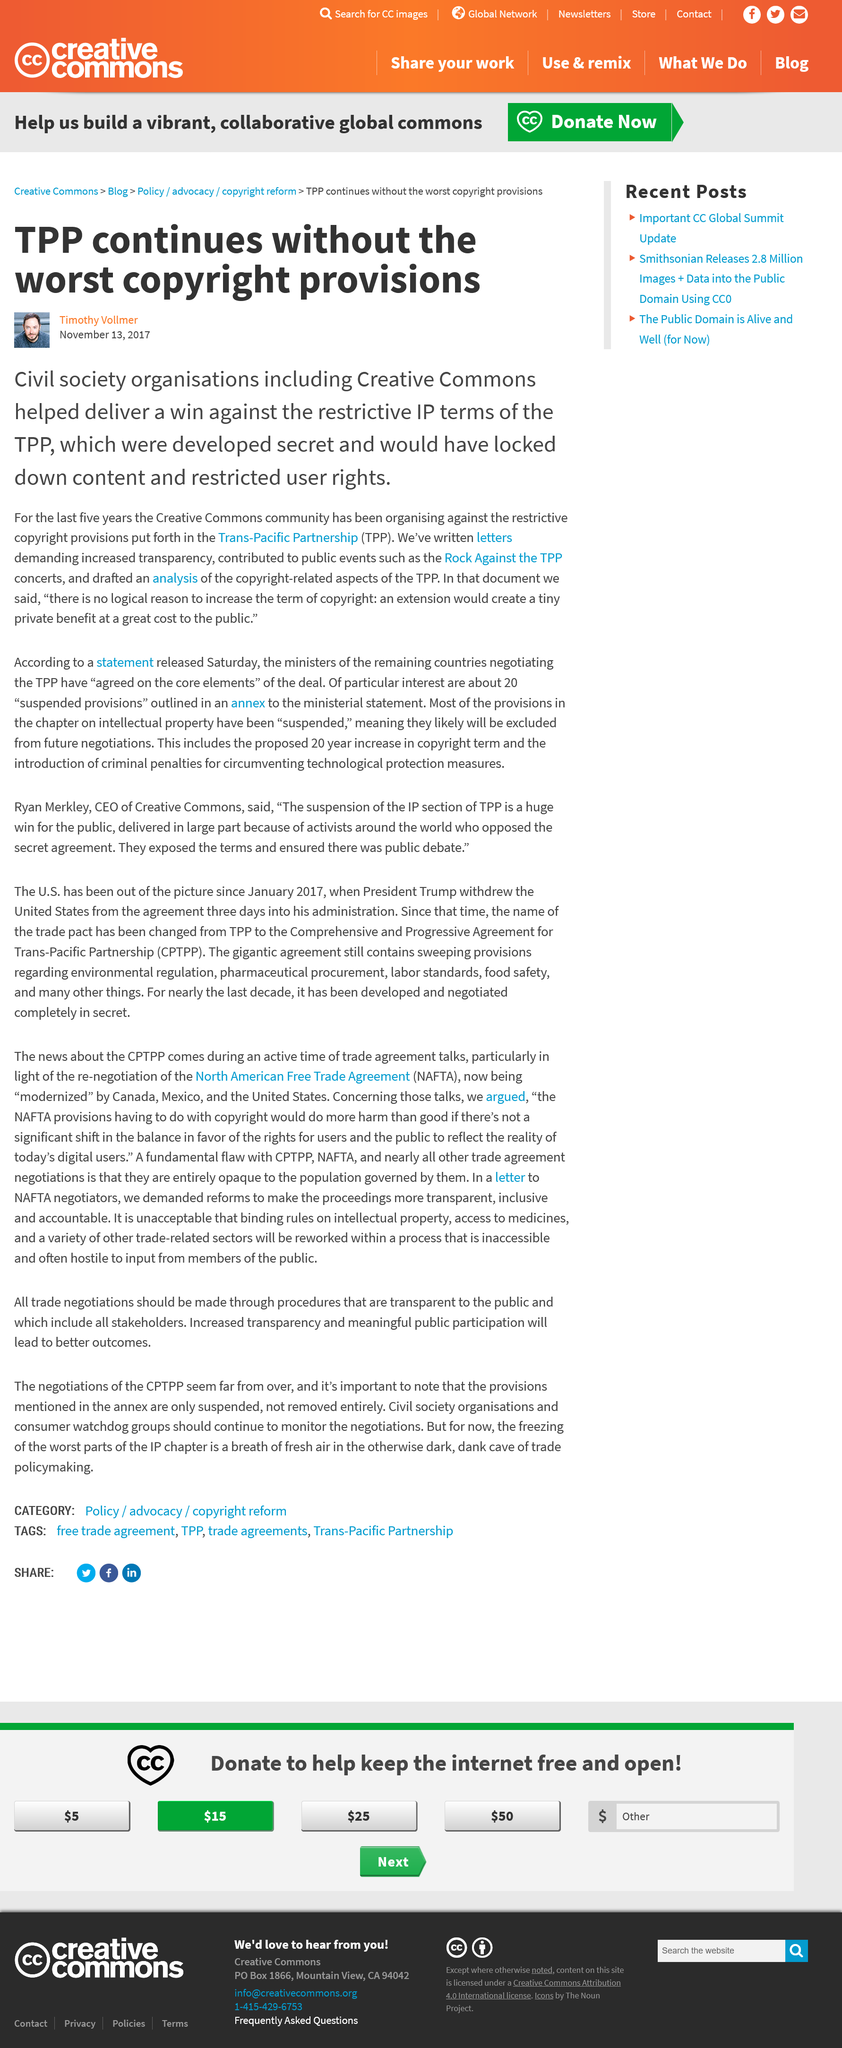Outline some significant characteristics in this image. The TPP continues to exist despite the removal of its most extreme copyright regulations. The Trans-Pacific Partnership is an agreement between several countries in the Pacific region that aims to promote free trade and economic growth. The article was published on November 13, 2017. 